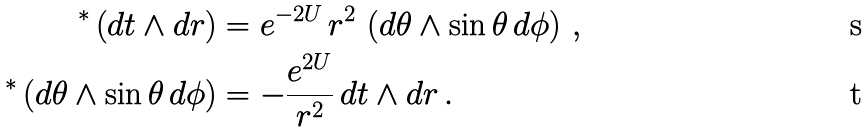<formula> <loc_0><loc_0><loc_500><loc_500>^ { * } \left ( d t \wedge d r \right ) & = e ^ { - 2 U } \, r ^ { 2 } \, \left ( d \theta \wedge \sin \theta \, d \phi \right ) \, , \\ ^ { * } \left ( d \theta \wedge \sin \theta \, d \phi \right ) & = - \frac { e ^ { 2 U } } { r ^ { 2 } } \, d t \wedge d r \, .</formula> 